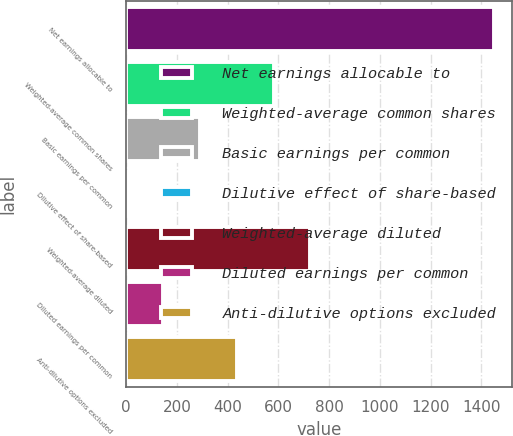Convert chart to OTSL. <chart><loc_0><loc_0><loc_500><loc_500><bar_chart><fcel>Net earnings allocable to<fcel>Weighted-average common shares<fcel>Basic earnings per common<fcel>Dilutive effect of share-based<fcel>Weighted-average diluted<fcel>Diluted earnings per common<fcel>Anti-dilutive options excluded<nl><fcel>1449<fcel>580.8<fcel>291.4<fcel>2<fcel>725.5<fcel>146.7<fcel>436.1<nl></chart> 